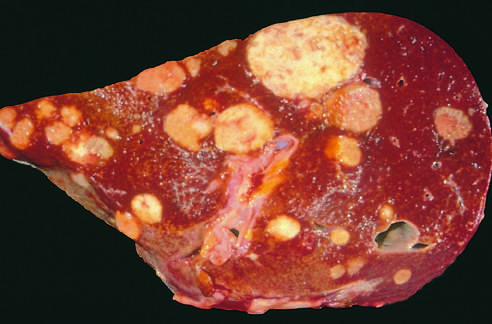s the late-phase reaction studded with metastatic cancer?
Answer the question using a single word or phrase. No 